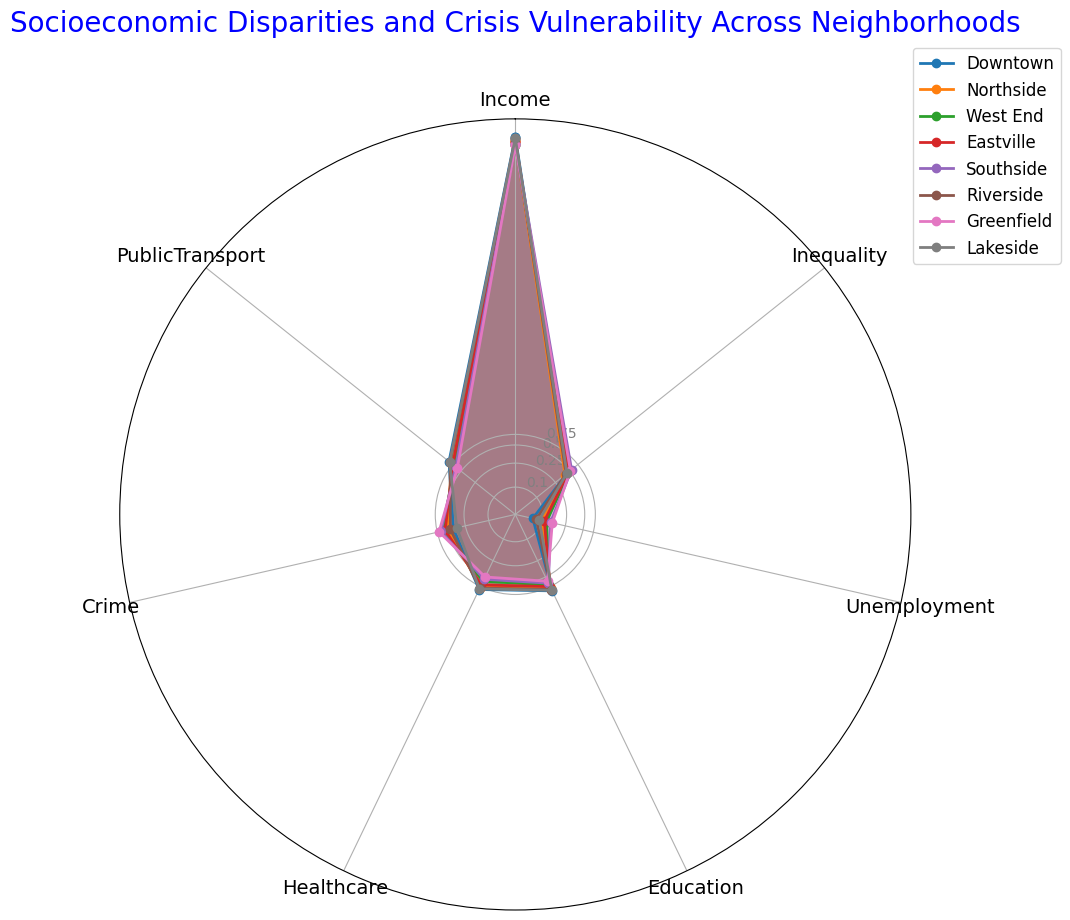What's the median value of Education levels across neighborhoods? To find the median, list the education values: [0.6, 0.65, 0.7, 0.75, 0.8, 0.85, 0.88, 0.9]. The median is the average of the two middle numbers in this sorted list (0.75 and 0.8), i.e., (0.75 + 0.8) / 2
Answer: 0.775 Which neighborhood has the highest income? According to the radar chart, Downtown has the highest income value plotted among the neighborhoods.
Answer: Downtown By how much does the inequality in Northside differ from that in Southside? The inequality values for Northside and Southside are 0.4 and 0.55 respectively. The difference is 0.55 - 0.4
Answer: 0.15 Compare the public transport availability between Greenfield and Downtown. Which is better? According to the radar chart, Greenfield's public transport value is 0.6, whereas Downtown's value is 0.9. Downtown has better public transport.
Answer: Downtown What is the range of crime values across all neighborhoods? The lowest crime value is in Lakeside (0.35) and the highest is in Greenfield (0.7). The range is 0.7 - 0.35
Answer: 0.35 Which neighborhood has the lowest unemployment rate? Based on the radar chart, Downtown has the lowest unemployment rate among the neighborhoods, marked at 0.07.
Answer: Downtown Are there any neighborhoods with identical public transport values? Northside and Eastville both have a public transport value of 0.8.
Answer: Northside, Eastville Compare the healthcare services between Riverside and Southside. Which neighborhood is better? Riverside's healthcare value is 0.8, while Southside’s value is 0.55. Thus, Riverside has better healthcare services.
Answer: Riverside Which neighborhood performs best in terms of Education? The radar chart shows that Downtown has the highest education value at 0.9 among all neighborhoods.
Answer: Downtown What is the average income of all neighborhoods combined? Summing up all the income values: 65000 + 55000 + 48000 + 53000 + 50000 + 60000 + 47000 + 62000 = 440000. Dividing by the number of neighborhoods (8), the average income is 440000 / 8
Answer: 55000 